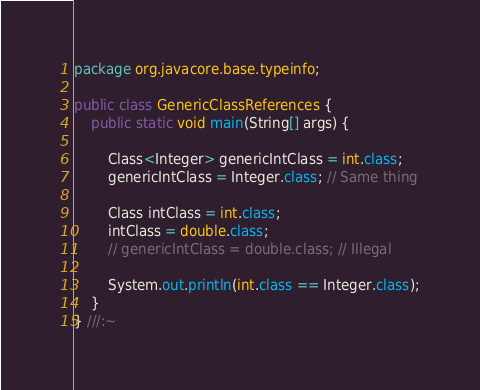Convert code to text. <code><loc_0><loc_0><loc_500><loc_500><_Java_>package org.javacore.base.typeinfo;

public class GenericClassReferences {
    public static void main(String[] args) {

        Class<Integer> genericIntClass = int.class;
        genericIntClass = Integer.class; // Same thing

        Class intClass = int.class;
        intClass = double.class;
        // genericIntClass = double.class; // Illegal

        System.out.println(int.class == Integer.class);
    }
} ///:~
</code> 